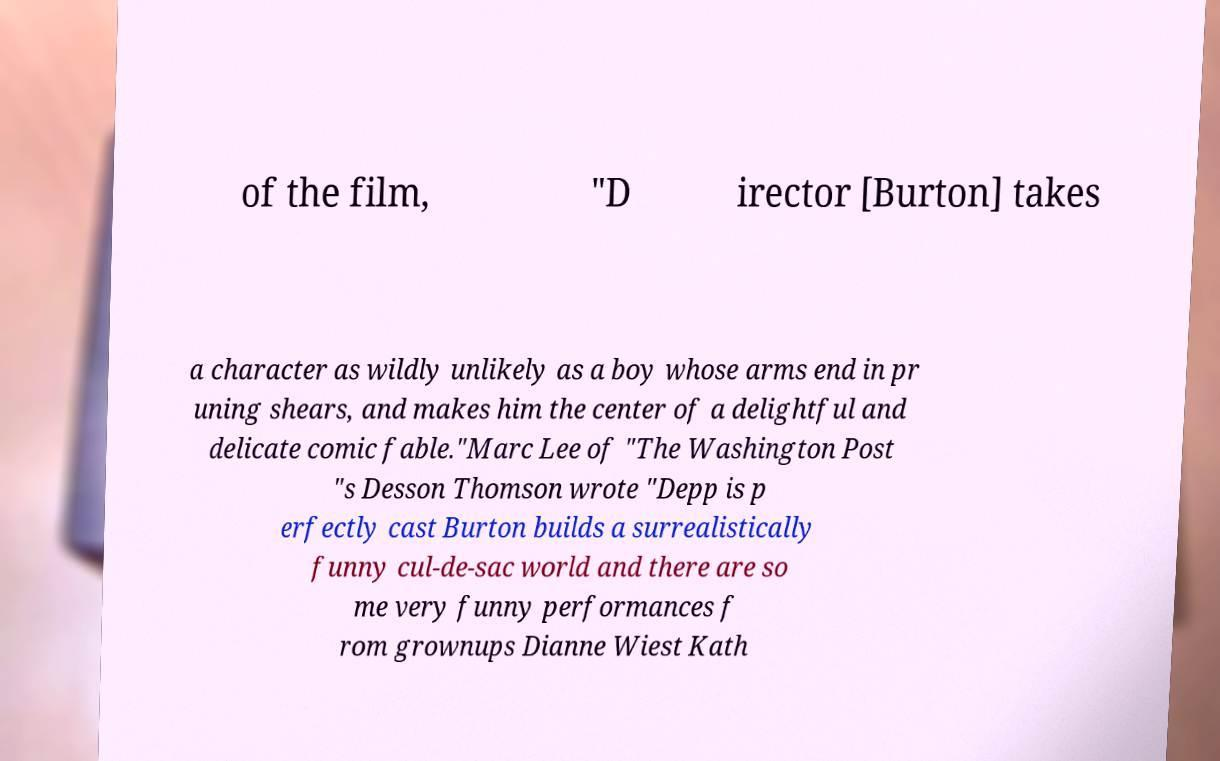What messages or text are displayed in this image? I need them in a readable, typed format. of the film, "D irector [Burton] takes a character as wildly unlikely as a boy whose arms end in pr uning shears, and makes him the center of a delightful and delicate comic fable."Marc Lee of "The Washington Post "s Desson Thomson wrote "Depp is p erfectly cast Burton builds a surrealistically funny cul-de-sac world and there are so me very funny performances f rom grownups Dianne Wiest Kath 